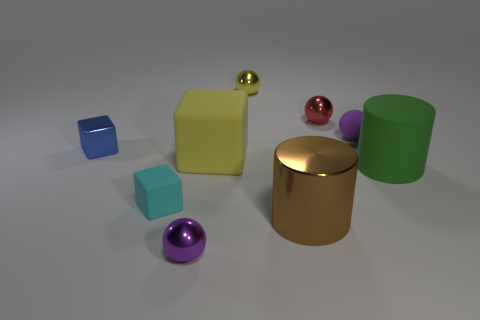Subtract all metal balls. How many balls are left? 1 Subtract all purple cylinders. How many purple balls are left? 2 Subtract all red spheres. How many spheres are left? 3 Subtract all gray balls. Subtract all cyan cylinders. How many balls are left? 4 Subtract all cylinders. How many objects are left? 7 Add 4 small purple spheres. How many small purple spheres exist? 6 Subtract 1 yellow blocks. How many objects are left? 8 Subtract all tiny shiny objects. Subtract all large gray matte cubes. How many objects are left? 5 Add 2 yellow blocks. How many yellow blocks are left? 3 